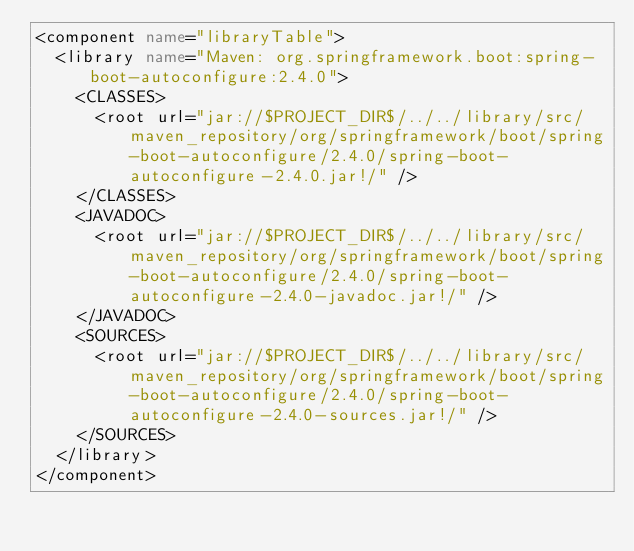<code> <loc_0><loc_0><loc_500><loc_500><_XML_><component name="libraryTable">
  <library name="Maven: org.springframework.boot:spring-boot-autoconfigure:2.4.0">
    <CLASSES>
      <root url="jar://$PROJECT_DIR$/../../library/src/maven_repository/org/springframework/boot/spring-boot-autoconfigure/2.4.0/spring-boot-autoconfigure-2.4.0.jar!/" />
    </CLASSES>
    <JAVADOC>
      <root url="jar://$PROJECT_DIR$/../../library/src/maven_repository/org/springframework/boot/spring-boot-autoconfigure/2.4.0/spring-boot-autoconfigure-2.4.0-javadoc.jar!/" />
    </JAVADOC>
    <SOURCES>
      <root url="jar://$PROJECT_DIR$/../../library/src/maven_repository/org/springframework/boot/spring-boot-autoconfigure/2.4.0/spring-boot-autoconfigure-2.4.0-sources.jar!/" />
    </SOURCES>
  </library>
</component></code> 